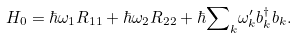<formula> <loc_0><loc_0><loc_500><loc_500>H _ { 0 } = \hbar { \omega } _ { 1 } R _ { 1 1 } + \hbar { \omega } _ { 2 } R _ { 2 2 } + \hbar { \sum } _ { k } \omega _ { k } ^ { \prime } b _ { k } ^ { \dagger } b _ { k } .</formula> 